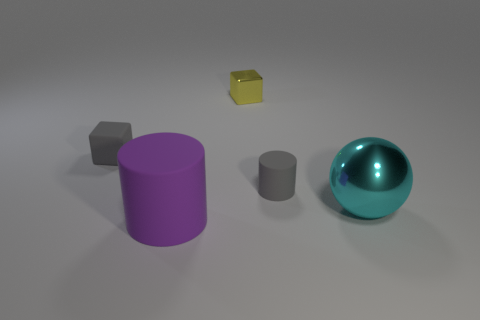What number of objects are matte objects that are behind the cyan metal object or cyan objects? There appears to be one matte object, a grey cube, behind the cyan metal sphere. To clarify, there is one cyan object, which is the metallic sphere, and it's not matte but has a reflective surface. 